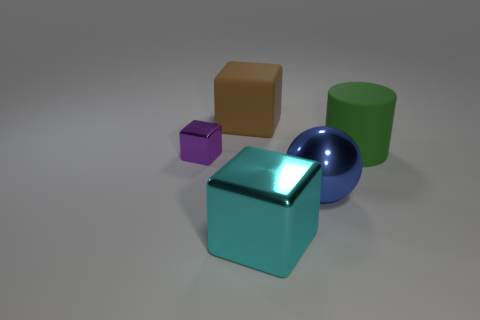Are there any large green things on the left side of the shiny block that is right of the shiny object behind the big blue object? Yes, there is a large green cylinder on the left side of the turquoise shiny block. This green object appears quite prominent in the scene. 